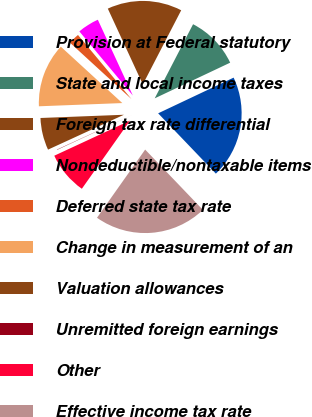Convert chart. <chart><loc_0><loc_0><loc_500><loc_500><pie_chart><fcel>Provision at Federal statutory<fcel>State and local income taxes<fcel>Foreign tax rate differential<fcel>Nondeductible/nontaxable items<fcel>Deferred state tax rate<fcel>Change in measurement of an<fcel>Valuation allowances<fcel>Unremitted foreign earnings<fcel>Other<fcel>Effective income tax rate<nl><fcel>19.88%<fcel>10.37%<fcel>14.49%<fcel>4.18%<fcel>2.12%<fcel>12.43%<fcel>6.24%<fcel>0.06%<fcel>8.3%<fcel>21.94%<nl></chart> 